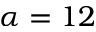<formula> <loc_0><loc_0><loc_500><loc_500>\alpha = 1 2</formula> 